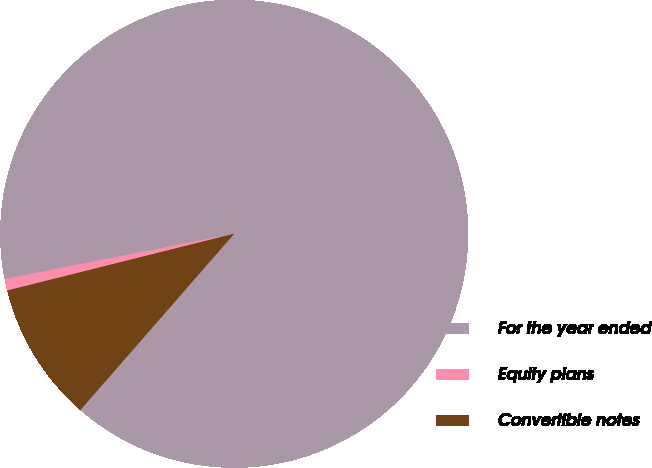Convert chart. <chart><loc_0><loc_0><loc_500><loc_500><pie_chart><fcel>For the year ended<fcel>Equity plans<fcel>Convertible notes<nl><fcel>89.53%<fcel>0.8%<fcel>9.67%<nl></chart> 